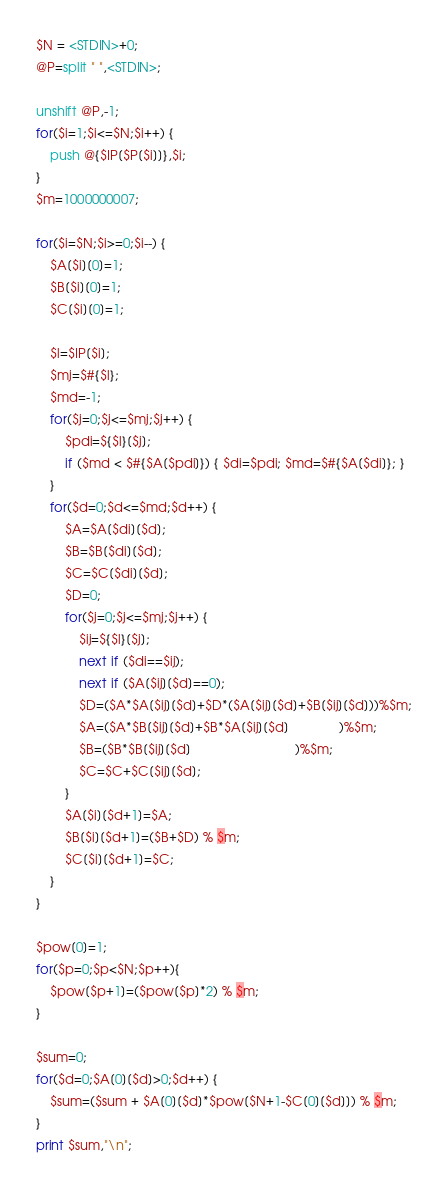<code> <loc_0><loc_0><loc_500><loc_500><_Perl_>$N = <STDIN>+0;
@P=split " ",<STDIN>;

unshift @P,-1;
for($i=1;$i<=$N;$i++) {
	push @{$IP[$P[$i]]},$i;
}
$m=1000000007;

for($i=$N;$i>=0;$i--) {
	$A[$i][0]=1;
	$B[$i][0]=1;
	$C[$i][0]=1;
	
	$l=$IP[$i];
	$mj=$#{$l};
	$md=-1;
	for($j=0;$j<=$mj;$j++) {
		$pdi=${$l}[$j];
		if ($md < $#{$A[$pdi]}) { $di=$pdi; $md=$#{$A[$di]}; }
	}
	for($d=0;$d<=$md;$d++) {
		$A=$A[$di][$d];
		$B=$B[$di][$d];
		$C=$C[$di][$d];
		$D=0;
		for($j=0;$j<=$mj;$j++) {
			$ij=${$l}[$j];
			next if ($di==$ij);
			next if ($A[$ij][$d]==0);
			$D=($A*$A[$ij][$d]+$D*($A[$ij][$d]+$B[$ij][$d]))%$m;
			$A=($A*$B[$ij][$d]+$B*$A[$ij][$d]              )%$m;
			$B=($B*$B[$ij][$d]                             )%$m;
			$C=$C+$C[$ij][$d];
		}
		$A[$i][$d+1]=$A;
		$B[$i][$d+1]=($B+$D) % $m;
		$C[$i][$d+1]=$C;
	}
}

$pow[0]=1;
for($p=0;$p<$N;$p++){
	$pow[$p+1]=($pow[$p]*2) % $m;
}

$sum=0;
for($d=0;$A[0][$d]>0;$d++) {
	$sum=($sum + $A[0][$d]*$pow[$N+1-$C[0][$d]]) % $m;
}
print $sum,"\n";</code> 